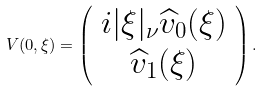<formula> <loc_0><loc_0><loc_500><loc_500>V ( 0 , \xi ) = \left ( \begin{array} { c } i | \xi | _ { \nu } \widehat { v } _ { 0 } ( \xi ) \\ \widehat { v } _ { 1 } ( \xi ) \end{array} \right ) .</formula> 